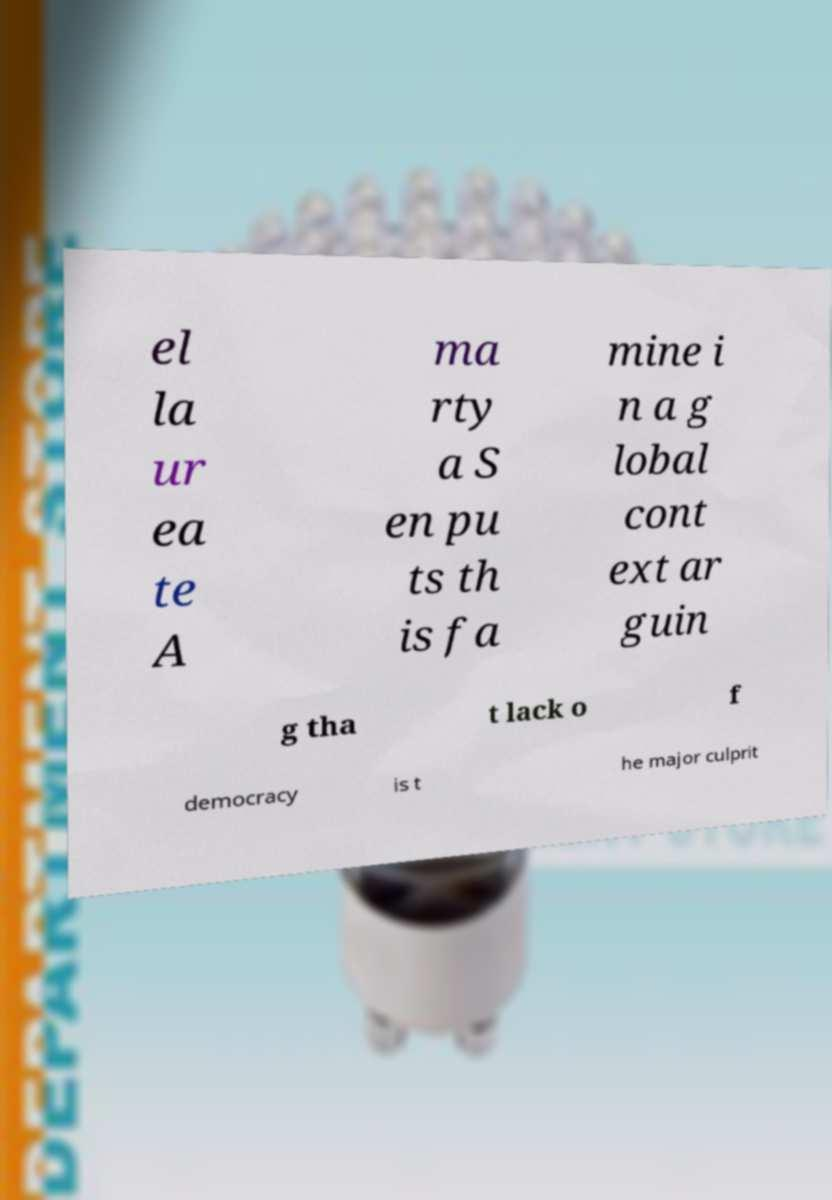I need the written content from this picture converted into text. Can you do that? el la ur ea te A ma rty a S en pu ts th is fa mine i n a g lobal cont ext ar guin g tha t lack o f democracy is t he major culprit 